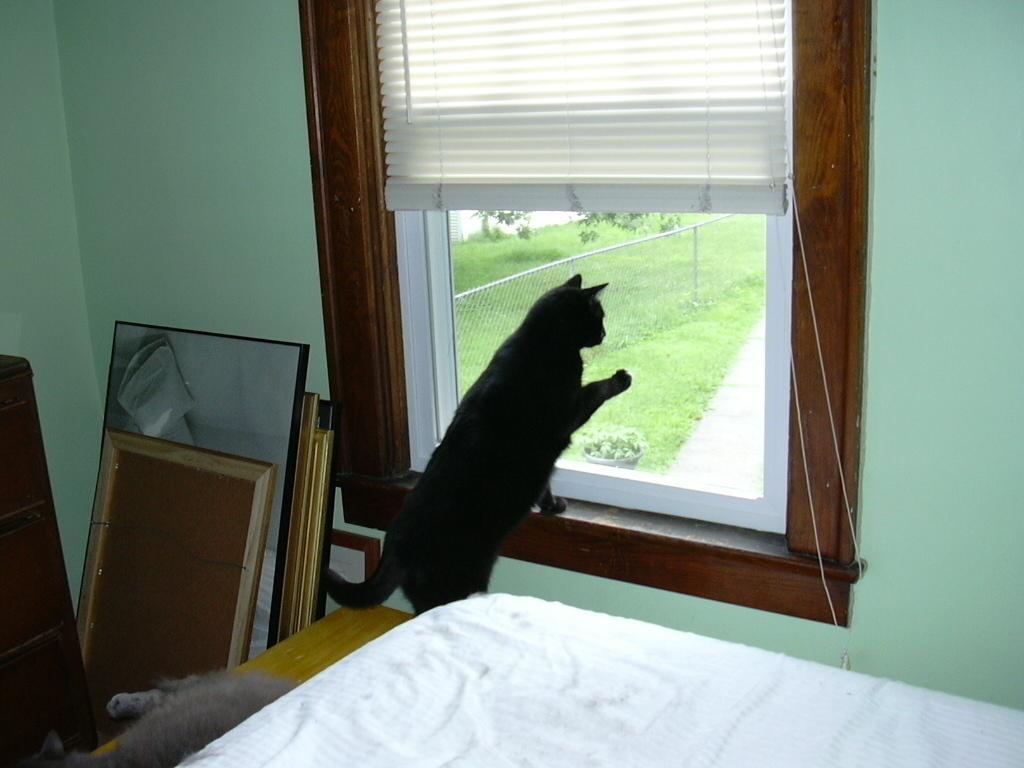In one or two sentences, can you explain what this image depicts? This is a picture of the inside of the house in this picture in the center there is one cat and one bed is there, and in the center there is one window and on the right side and left side there is a wall and some glass sheets are there and in the bottom there is another cat. 